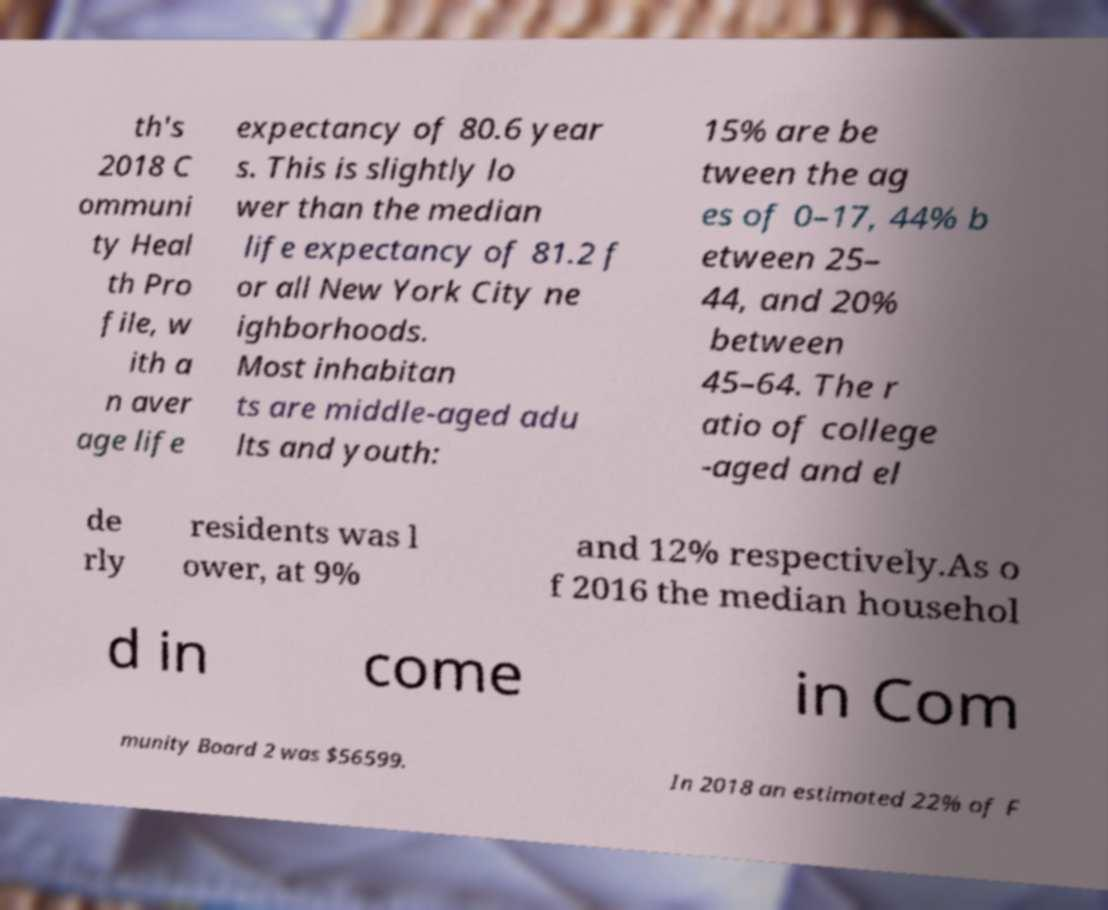There's text embedded in this image that I need extracted. Can you transcribe it verbatim? th's 2018 C ommuni ty Heal th Pro file, w ith a n aver age life expectancy of 80.6 year s. This is slightly lo wer than the median life expectancy of 81.2 f or all New York City ne ighborhoods. Most inhabitan ts are middle-aged adu lts and youth: 15% are be tween the ag es of 0–17, 44% b etween 25– 44, and 20% between 45–64. The r atio of college -aged and el de rly residents was l ower, at 9% and 12% respectively.As o f 2016 the median househol d in come in Com munity Board 2 was $56599. In 2018 an estimated 22% of F 